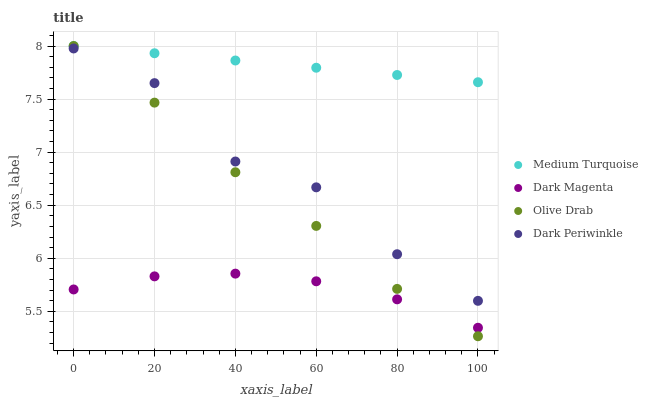Does Dark Magenta have the minimum area under the curve?
Answer yes or no. Yes. Does Medium Turquoise have the maximum area under the curve?
Answer yes or no. Yes. Does Medium Turquoise have the minimum area under the curve?
Answer yes or no. No. Does Dark Magenta have the maximum area under the curve?
Answer yes or no. No. Is Medium Turquoise the smoothest?
Answer yes or no. Yes. Is Dark Periwinkle the roughest?
Answer yes or no. Yes. Is Dark Magenta the smoothest?
Answer yes or no. No. Is Dark Magenta the roughest?
Answer yes or no. No. Does Olive Drab have the lowest value?
Answer yes or no. Yes. Does Dark Magenta have the lowest value?
Answer yes or no. No. Does Medium Turquoise have the highest value?
Answer yes or no. Yes. Does Dark Magenta have the highest value?
Answer yes or no. No. Is Dark Periwinkle less than Medium Turquoise?
Answer yes or no. Yes. Is Medium Turquoise greater than Dark Magenta?
Answer yes or no. Yes. Does Olive Drab intersect Dark Magenta?
Answer yes or no. Yes. Is Olive Drab less than Dark Magenta?
Answer yes or no. No. Is Olive Drab greater than Dark Magenta?
Answer yes or no. No. Does Dark Periwinkle intersect Medium Turquoise?
Answer yes or no. No. 